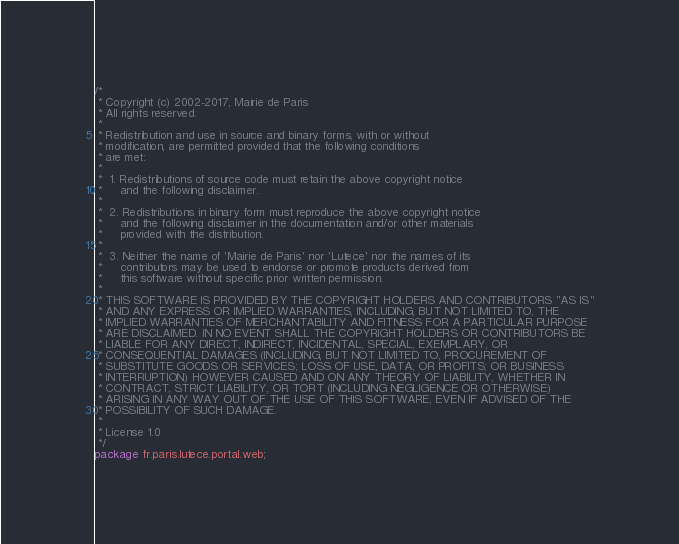Convert code to text. <code><loc_0><loc_0><loc_500><loc_500><_Java_>/*
 * Copyright (c) 2002-2017, Mairie de Paris
 * All rights reserved.
 *
 * Redistribution and use in source and binary forms, with or without
 * modification, are permitted provided that the following conditions
 * are met:
 *
 *  1. Redistributions of source code must retain the above copyright notice
 *     and the following disclaimer.
 *
 *  2. Redistributions in binary form must reproduce the above copyright notice
 *     and the following disclaimer in the documentation and/or other materials
 *     provided with the distribution.
 *
 *  3. Neither the name of 'Mairie de Paris' nor 'Lutece' nor the names of its
 *     contributors may be used to endorse or promote products derived from
 *     this software without specific prior written permission.
 *
 * THIS SOFTWARE IS PROVIDED BY THE COPYRIGHT HOLDERS AND CONTRIBUTORS "AS IS"
 * AND ANY EXPRESS OR IMPLIED WARRANTIES, INCLUDING, BUT NOT LIMITED TO, THE
 * IMPLIED WARRANTIES OF MERCHANTABILITY AND FITNESS FOR A PARTICULAR PURPOSE
 * ARE DISCLAIMED. IN NO EVENT SHALL THE COPYRIGHT HOLDERS OR CONTRIBUTORS BE
 * LIABLE FOR ANY DIRECT, INDIRECT, INCIDENTAL, SPECIAL, EXEMPLARY, OR
 * CONSEQUENTIAL DAMAGES (INCLUDING, BUT NOT LIMITED TO, PROCUREMENT OF
 * SUBSTITUTE GOODS OR SERVICES; LOSS OF USE, DATA, OR PROFITS; OR BUSINESS
 * INTERRUPTION) HOWEVER CAUSED AND ON ANY THEORY OF LIABILITY, WHETHER IN
 * CONTRACT, STRICT LIABILITY, OR TORT (INCLUDING NEGLIGENCE OR OTHERWISE)
 * ARISING IN ANY WAY OUT OF THE USE OF THIS SOFTWARE, EVEN IF ADVISED OF THE
 * POSSIBILITY OF SUCH DAMAGE.
 *
 * License 1.0
 */
package fr.paris.lutece.portal.web;
</code> 